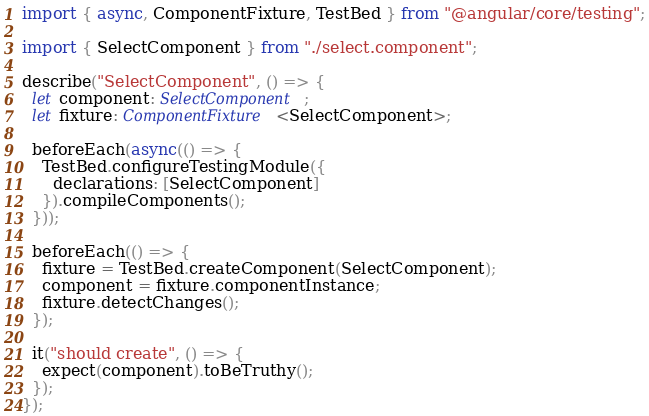Convert code to text. <code><loc_0><loc_0><loc_500><loc_500><_TypeScript_>import { async, ComponentFixture, TestBed } from "@angular/core/testing";

import { SelectComponent } from "./select.component";

describe("SelectComponent", () => {
  let component: SelectComponent;
  let fixture: ComponentFixture<SelectComponent>;

  beforeEach(async(() => {
    TestBed.configureTestingModule({
      declarations: [SelectComponent]
    }).compileComponents();
  }));

  beforeEach(() => {
    fixture = TestBed.createComponent(SelectComponent);
    component = fixture.componentInstance;
    fixture.detectChanges();
  });

  it("should create", () => {
    expect(component).toBeTruthy();
  });
});
</code> 